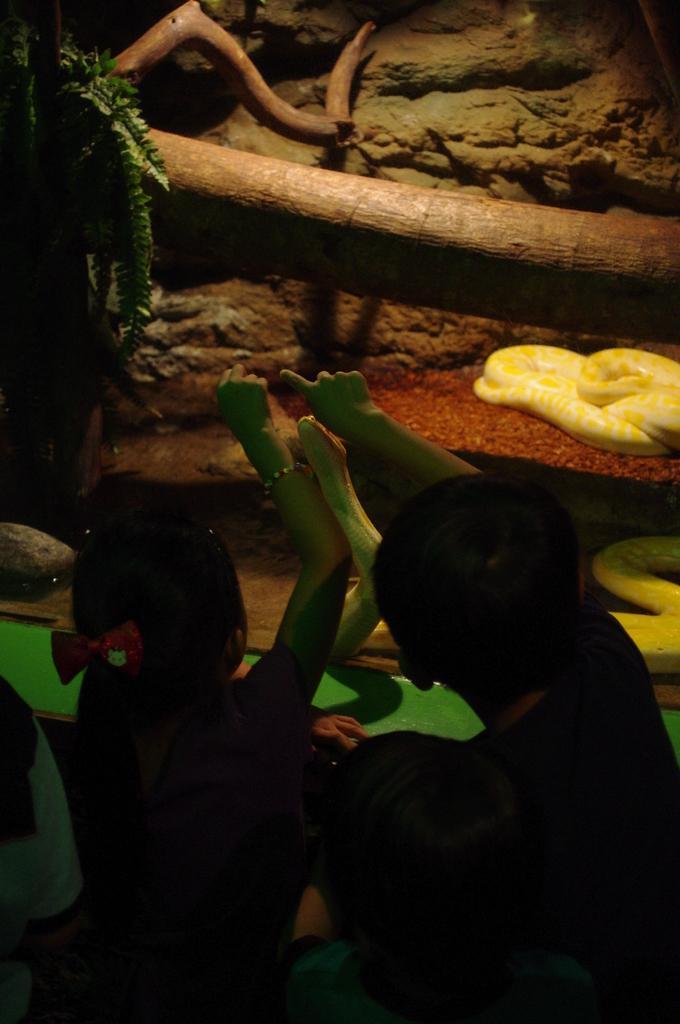Could you give a brief overview of what you see in this image? Here people are standing, this is snake and a plant. 